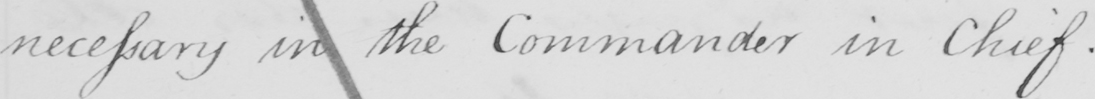Transcribe the text shown in this historical manuscript line. necessary in the Commander in Chief. 